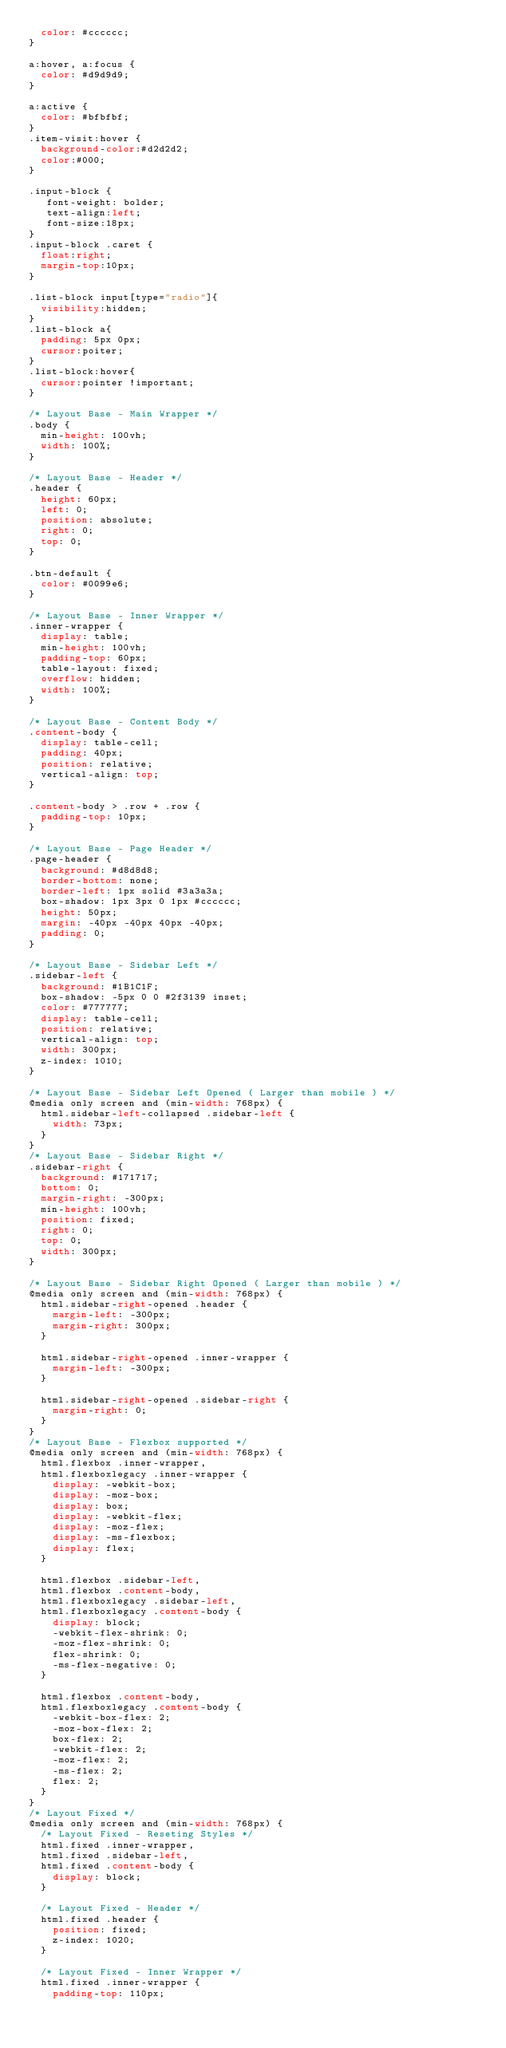Convert code to text. <code><loc_0><loc_0><loc_500><loc_500><_CSS_>	color: #cccccc;
}

a:hover, a:focus {
	color: #d9d9d9;
}

a:active {
	color: #bfbfbf;
}
.item-visit:hover {
	background-color:#d2d2d2;
	color:#000;
}

.input-block {
   font-weight: bolder;
   text-align:left;
   font-size:18px;
}
.input-block .caret {
	float:right;
	margin-top:10px;
}

.list-block input[type="radio"]{
 	visibility:hidden;
}
.list-block a{
	padding: 5px 0px;
	cursor:poiter;
}
.list-block:hover{
	cursor:pointer !important;
}

/* Layout Base - Main Wrapper	*/
.body {
	min-height: 100vh;
	width: 100%;
}

/* Layout Base - Header */
.header {
	height: 60px;
	left: 0;
	position: absolute;
	right: 0;
	top: 0;
}

.btn-default {
	color: #0099e6;
}

/* Layout Base - Inner Wrapper */
.inner-wrapper {
	display: table;
	min-height: 100vh;
	padding-top: 60px;
	table-layout: fixed;
	overflow: hidden;
	width: 100%;
}

/* Layout Base - Content Body */
.content-body {
	display: table-cell;
	padding: 40px;
	position: relative;
	vertical-align: top;
}

.content-body > .row + .row {
	padding-top: 10px;
}

/* Layout Base - Page Header */
.page-header {
	background: #d8d8d8;
	border-bottom: none;
	border-left: 1px solid #3a3a3a;
	box-shadow: 1px 3px 0 1px #cccccc;
	height: 50px;
	margin: -40px -40px 40px -40px;
	padding: 0;
}

/* Layout Base - Sidebar Left */
.sidebar-left {
	background: #1B1C1F;
	box-shadow: -5px 0 0 #2f3139 inset;
	color: #777777;
	display: table-cell;
	position: relative;
	vertical-align: top;
	width: 300px;
	z-index: 1010;
}

/* Layout Base - Sidebar Left Opened ( Larger than mobile ) */
@media only screen and (min-width: 768px) {
	html.sidebar-left-collapsed .sidebar-left {
		width: 73px;
	}
}
/* Layout Base - Sidebar Right */
.sidebar-right {
	background: #171717;
	bottom: 0;
	margin-right: -300px;
	min-height: 100vh;
	position: fixed;
	right: 0;
	top: 0;
	width: 300px;
}

/* Layout Base - Sidebar Right Opened ( Larger than mobile ) */
@media only screen and (min-width: 768px) {
	html.sidebar-right-opened .header {
		margin-left: -300px;
		margin-right: 300px;
	}

	html.sidebar-right-opened .inner-wrapper {
		margin-left: -300px;
	}

	html.sidebar-right-opened .sidebar-right {
		margin-right: 0;
	}
}
/* Layout Base - Flexbox supported */
@media only screen and (min-width: 768px) {
	html.flexbox .inner-wrapper,
	html.flexboxlegacy .inner-wrapper {
		display: -webkit-box;
		display: -moz-box;
		display: box;
		display: -webkit-flex;
		display: -moz-flex;
		display: -ms-flexbox;
		display: flex;
	}

	html.flexbox .sidebar-left,
	html.flexbox .content-body,
	html.flexboxlegacy .sidebar-left,
	html.flexboxlegacy .content-body {
		display: block;
		-webkit-flex-shrink: 0;
		-moz-flex-shrink: 0;
		flex-shrink: 0;
		-ms-flex-negative: 0;
	}

	html.flexbox .content-body,
	html.flexboxlegacy .content-body {
		-webkit-box-flex: 2;
		-moz-box-flex: 2;
		box-flex: 2;
		-webkit-flex: 2;
		-moz-flex: 2;
		-ms-flex: 2;
		flex: 2;
	}
}
/* Layout Fixed */
@media only screen and (min-width: 768px) {
	/* Layout Fixed - Reseting Styles */
	html.fixed .inner-wrapper,
	html.fixed .sidebar-left,
	html.fixed .content-body {
		display: block;
	}

	/* Layout Fixed - Header */
	html.fixed .header {
		position: fixed;
		z-index: 1020;
	}

	/* Layout Fixed - Inner Wrapper */
	html.fixed .inner-wrapper {
		padding-top: 110px;</code> 